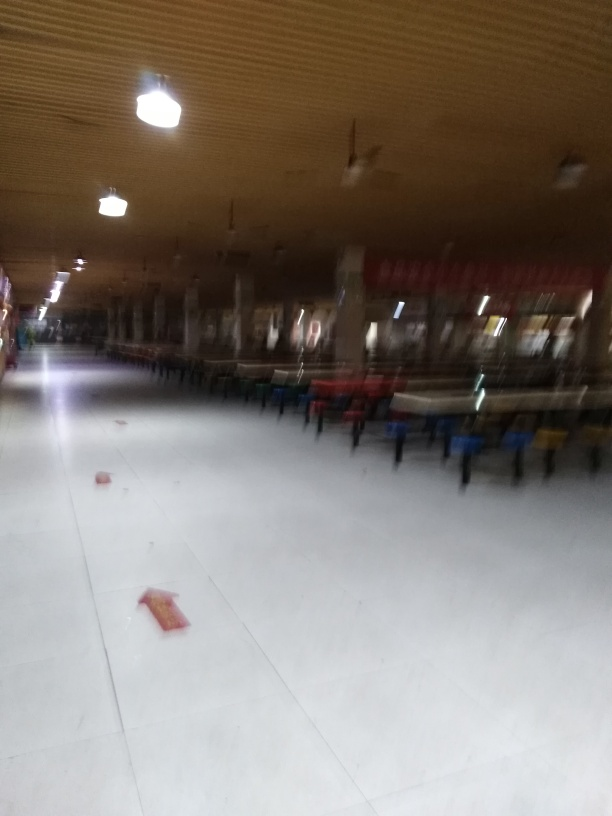Can you describe the lighting in the image? The lighting in the image is provided by overhead fixtures, which emit a bright light that reflects off the floor. However, the image is slightly overexposed due to the camera's inability to handle the bright light sources directly in the shot. 